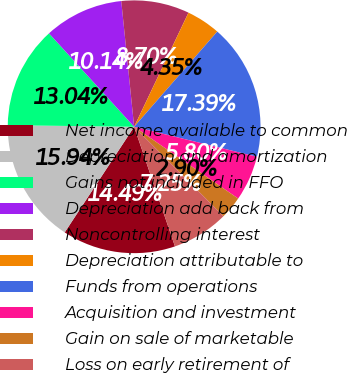<chart> <loc_0><loc_0><loc_500><loc_500><pie_chart><fcel>Net income available to common<fcel>Depreciation and amortization<fcel>Gains not included in FFO<fcel>Depreciation add back from<fcel>Noncontrolling interest<fcel>Depreciation attributable to<fcel>Funds from operations<fcel>Acquisition and investment<fcel>Gain on sale of marketable<fcel>Loss on early retirement of<nl><fcel>14.49%<fcel>15.94%<fcel>13.04%<fcel>10.14%<fcel>8.7%<fcel>4.35%<fcel>17.39%<fcel>5.8%<fcel>2.9%<fcel>7.25%<nl></chart> 